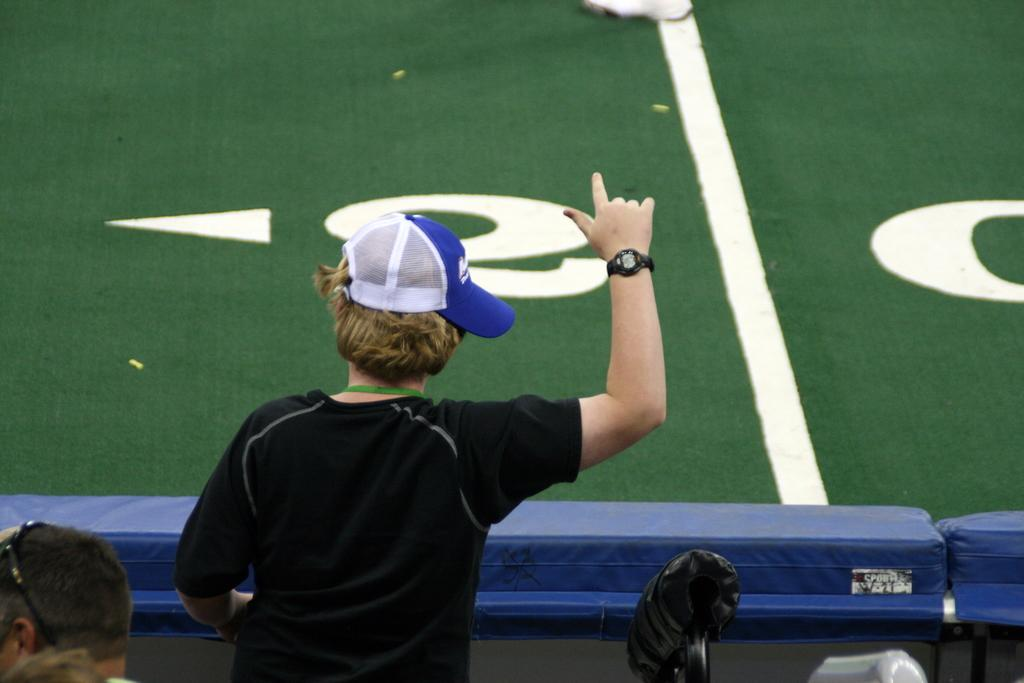What is the main subject of the image? There is a person in the image. What can be seen on the person's head? The person is wearing a cap on their head. What accessory is the person wearing on their right hand? The person is wearing a watch on their right hand. What color is the floor in the image? The floor in the image is green. What type of plantation can be seen in the background of the image? There is no plantation visible in the image; it only features a person with a cap and a watch, and a green floor. How many women are present in the image? There is no mention of any women in the image; it only features a person who could be of any gender. 